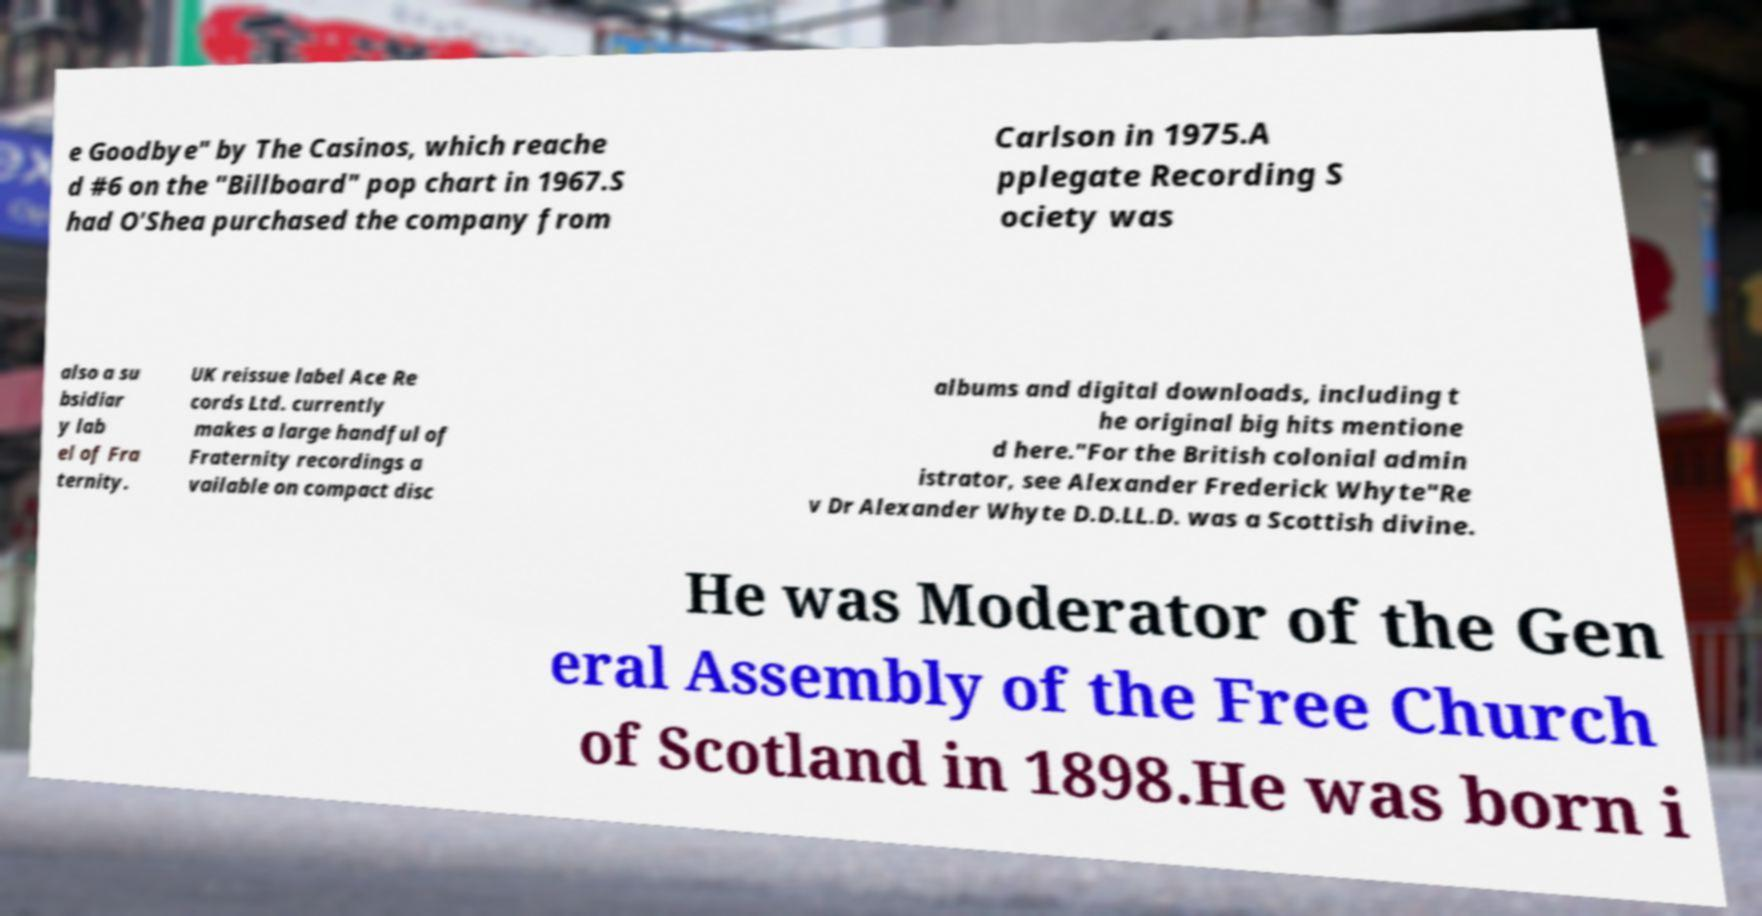I need the written content from this picture converted into text. Can you do that? e Goodbye" by The Casinos, which reache d #6 on the "Billboard" pop chart in 1967.S had O'Shea purchased the company from Carlson in 1975.A pplegate Recording S ociety was also a su bsidiar y lab el of Fra ternity. UK reissue label Ace Re cords Ltd. currently makes a large handful of Fraternity recordings a vailable on compact disc albums and digital downloads, including t he original big hits mentione d here."For the British colonial admin istrator, see Alexander Frederick Whyte"Re v Dr Alexander Whyte D.D.LL.D. was a Scottish divine. He was Moderator of the Gen eral Assembly of the Free Church of Scotland in 1898.He was born i 